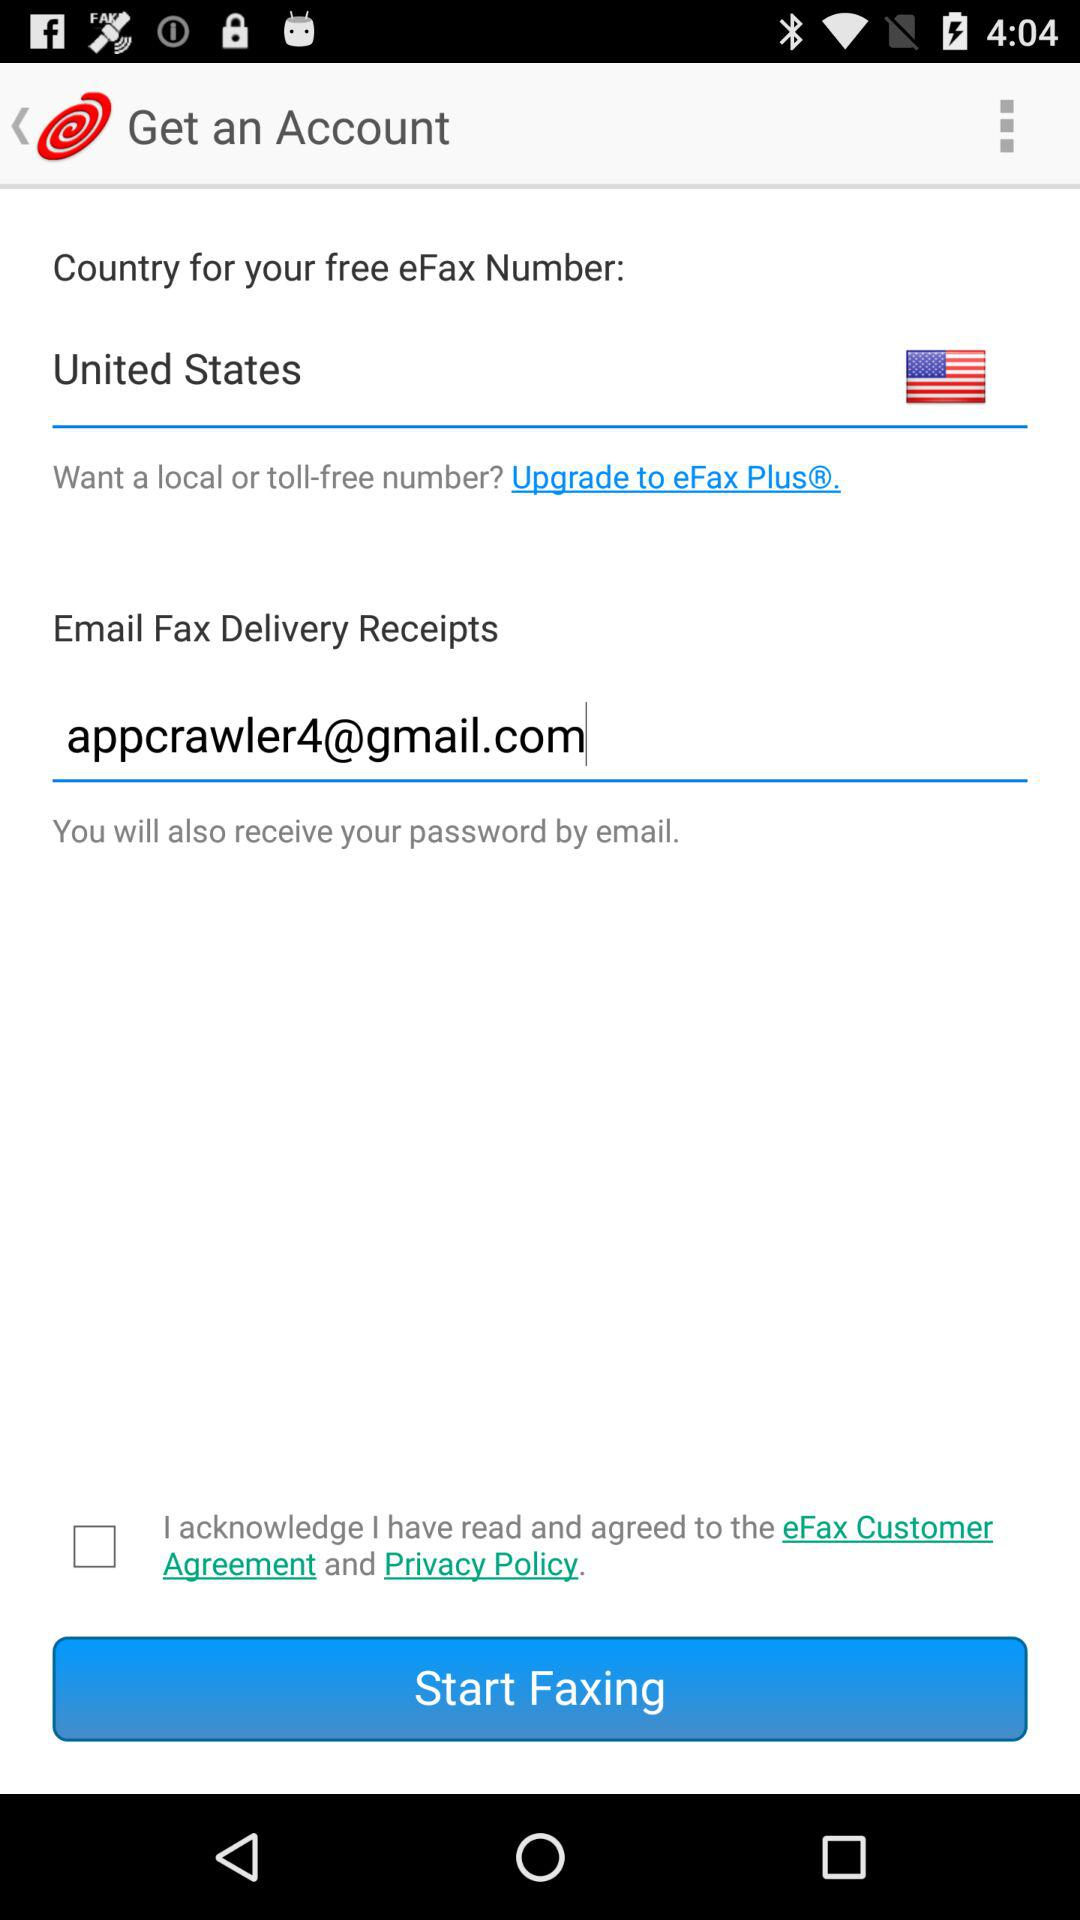How many text inputs are there that are not empty?
Answer the question using a single word or phrase. 1 